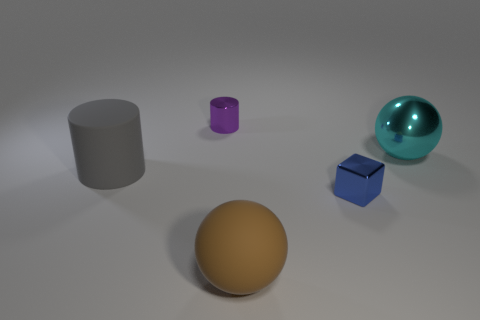Add 1 large yellow metallic cubes. How many objects exist? 6 Subtract all cylinders. How many objects are left? 3 Subtract all blue spheres. Subtract all green cubes. How many spheres are left? 2 Subtract all purple blocks. How many green spheres are left? 0 Subtract all cyan spheres. Subtract all small purple metal things. How many objects are left? 3 Add 2 big brown things. How many big brown things are left? 3 Add 4 big green spheres. How many big green spheres exist? 4 Subtract all cyan spheres. How many spheres are left? 1 Subtract 0 red spheres. How many objects are left? 5 Subtract 1 balls. How many balls are left? 1 